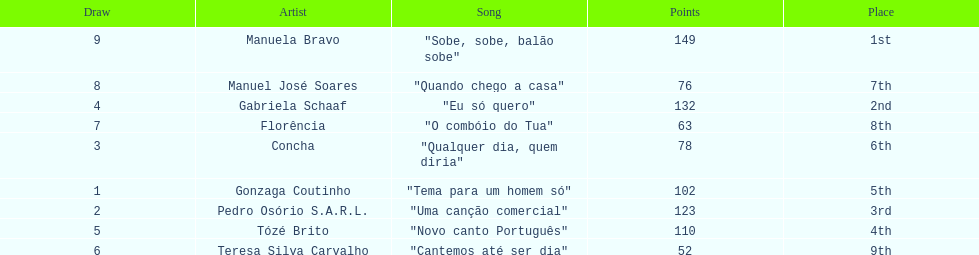What is the total amount of points for florencia? 63. Would you be able to parse every entry in this table? {'header': ['Draw', 'Artist', 'Song', 'Points', 'Place'], 'rows': [['9', 'Manuela Bravo', '"Sobe, sobe, balão sobe"', '149', '1st'], ['8', 'Manuel José Soares', '"Quando chego a casa"', '76', '7th'], ['4', 'Gabriela Schaaf', '"Eu só quero"', '132', '2nd'], ['7', 'Florência', '"O combóio do Tua"', '63', '8th'], ['3', 'Concha', '"Qualquer dia, quem diria"', '78', '6th'], ['1', 'Gonzaga Coutinho', '"Tema para um homem só"', '102', '5th'], ['2', 'Pedro Osório S.A.R.L.', '"Uma canção comercial"', '123', '3rd'], ['5', 'Tózé Brito', '"Novo canto Português"', '110', '4th'], ['6', 'Teresa Silva Carvalho', '"Cantemos até ser dia"', '52', '9th']]} 